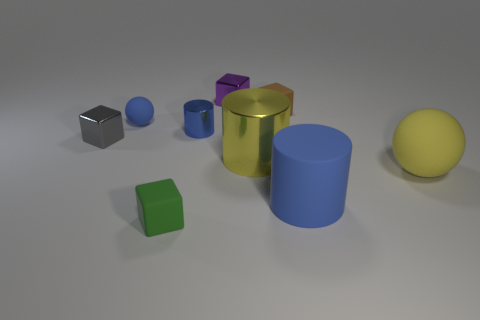Are there any two objects that look exactly the same in shape and size? No, each object in the image has a distinct shape and size. There are no two objects that are exact matches in both of these attributes. 